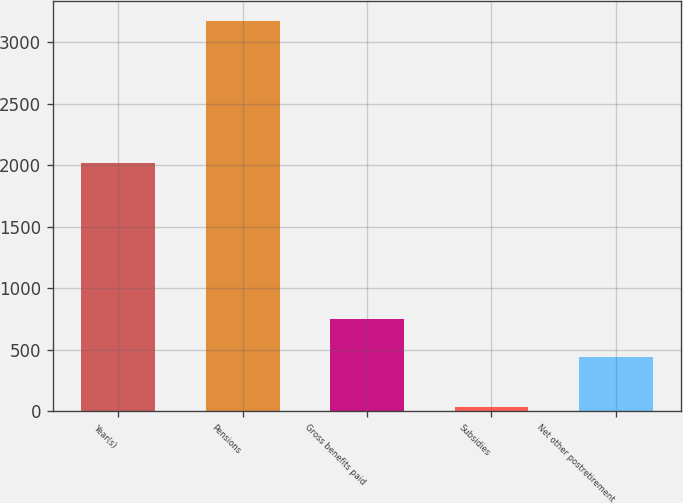<chart> <loc_0><loc_0><loc_500><loc_500><bar_chart><fcel>Year(s)<fcel>Pensions<fcel>Gross benefits paid<fcel>Subsidies<fcel>Net other postretirement<nl><fcel>2014<fcel>3173<fcel>752.4<fcel>39<fcel>439<nl></chart> 